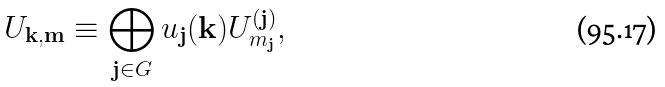<formula> <loc_0><loc_0><loc_500><loc_500>U _ { \mathbf k , \mathbf m } \equiv \bigoplus _ { \mathbf j \in G } u _ { \mathbf j } ( \mathbf k ) U _ { m _ { \mathbf j } } ^ { ( \mathbf j ) } ,</formula> 